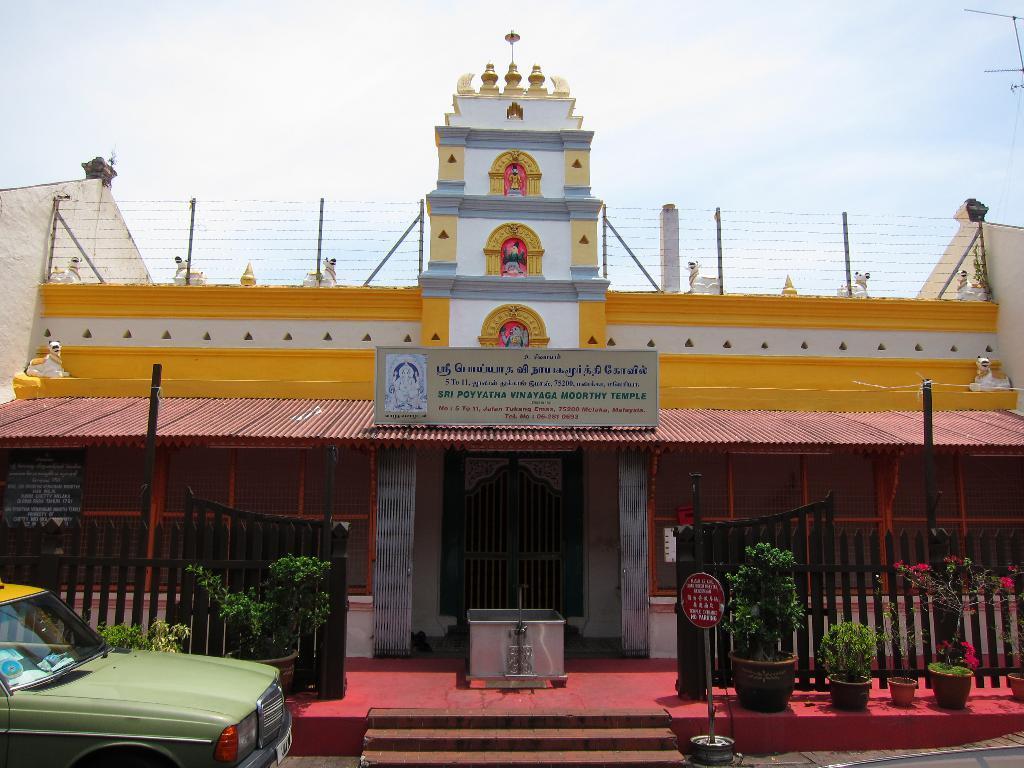Please provide a concise description of this image. This picture is clicked outside. On the left corner we can see a vehicle. In the center we can see the stairs and a podium and the metal gate and we can see the boards on which we can see the text and some pictures. In the foreground we can see the potted plants and the fence and some metal rods. At the top we can see the metal rods and the sculptures of some objects and we can see the house. In the background we can see the sky. 